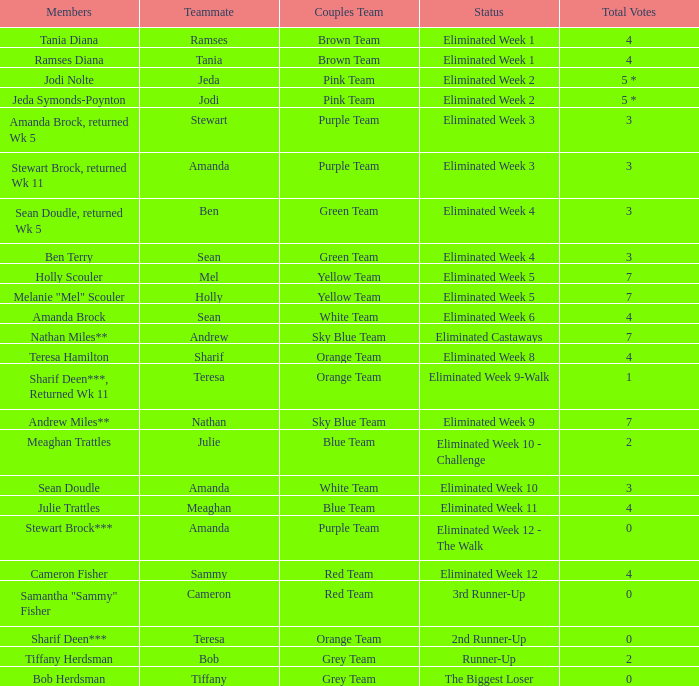What was Holly Scouler's total votes 7.0. 